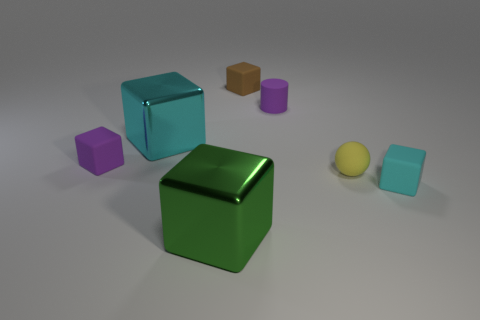Is the size of the green object the same as the cyan thing left of the brown thing?
Keep it short and to the point. Yes. What number of things are rubber cubes that are left of the rubber sphere or objects right of the small purple cube?
Your answer should be compact. 7. What is the color of the block in front of the cyan rubber object?
Your response must be concise. Green. Are there any objects behind the purple thing that is on the left side of the purple cylinder?
Your response must be concise. Yes. Is the number of tiny yellow metallic cylinders less than the number of tiny cylinders?
Offer a terse response. Yes. What material is the big cube in front of the small yellow matte sphere that is on the left side of the small cyan block made of?
Your response must be concise. Metal. Does the cyan matte object have the same size as the brown matte thing?
Ensure brevity in your answer.  Yes. What number of things are either green metal balls or brown rubber blocks?
Keep it short and to the point. 1. What is the size of the matte block that is behind the cyan rubber object and on the right side of the cyan metal block?
Ensure brevity in your answer.  Small. Is the number of small balls behind the purple matte cylinder less than the number of green matte things?
Your answer should be very brief. No. 